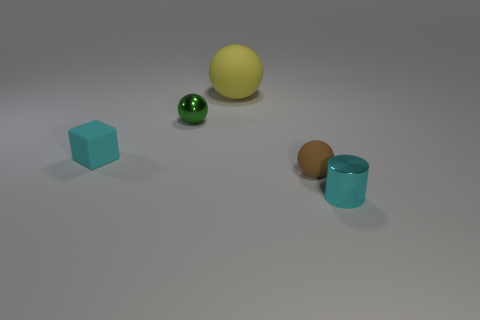Subtract all matte spheres. How many spheres are left? 1 Add 3 metal cylinders. How many objects exist? 8 Subtract all green balls. How many balls are left? 2 Subtract all cylinders. How many objects are left? 4 Add 4 tiny blocks. How many tiny blocks exist? 5 Subtract 0 purple cubes. How many objects are left? 5 Subtract all purple cubes. Subtract all cyan balls. How many cubes are left? 1 Subtract all yellow cylinders. Subtract all tiny metal cylinders. How many objects are left? 4 Add 3 spheres. How many spheres are left? 6 